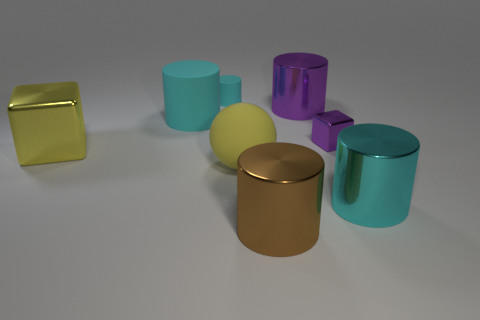Subtract all small matte cylinders. How many cylinders are left? 4 Add 1 large cyan cylinders. How many objects exist? 9 Subtract 2 cylinders. How many cylinders are left? 3 Subtract all purple cylinders. How many cylinders are left? 4 Subtract all balls. How many objects are left? 7 Subtract all brown blocks. How many cyan cylinders are left? 3 Subtract all big purple metal objects. Subtract all purple metal cylinders. How many objects are left? 6 Add 6 cyan shiny cylinders. How many cyan shiny cylinders are left? 7 Add 4 tiny cyan matte things. How many tiny cyan matte things exist? 5 Subtract 0 red cylinders. How many objects are left? 8 